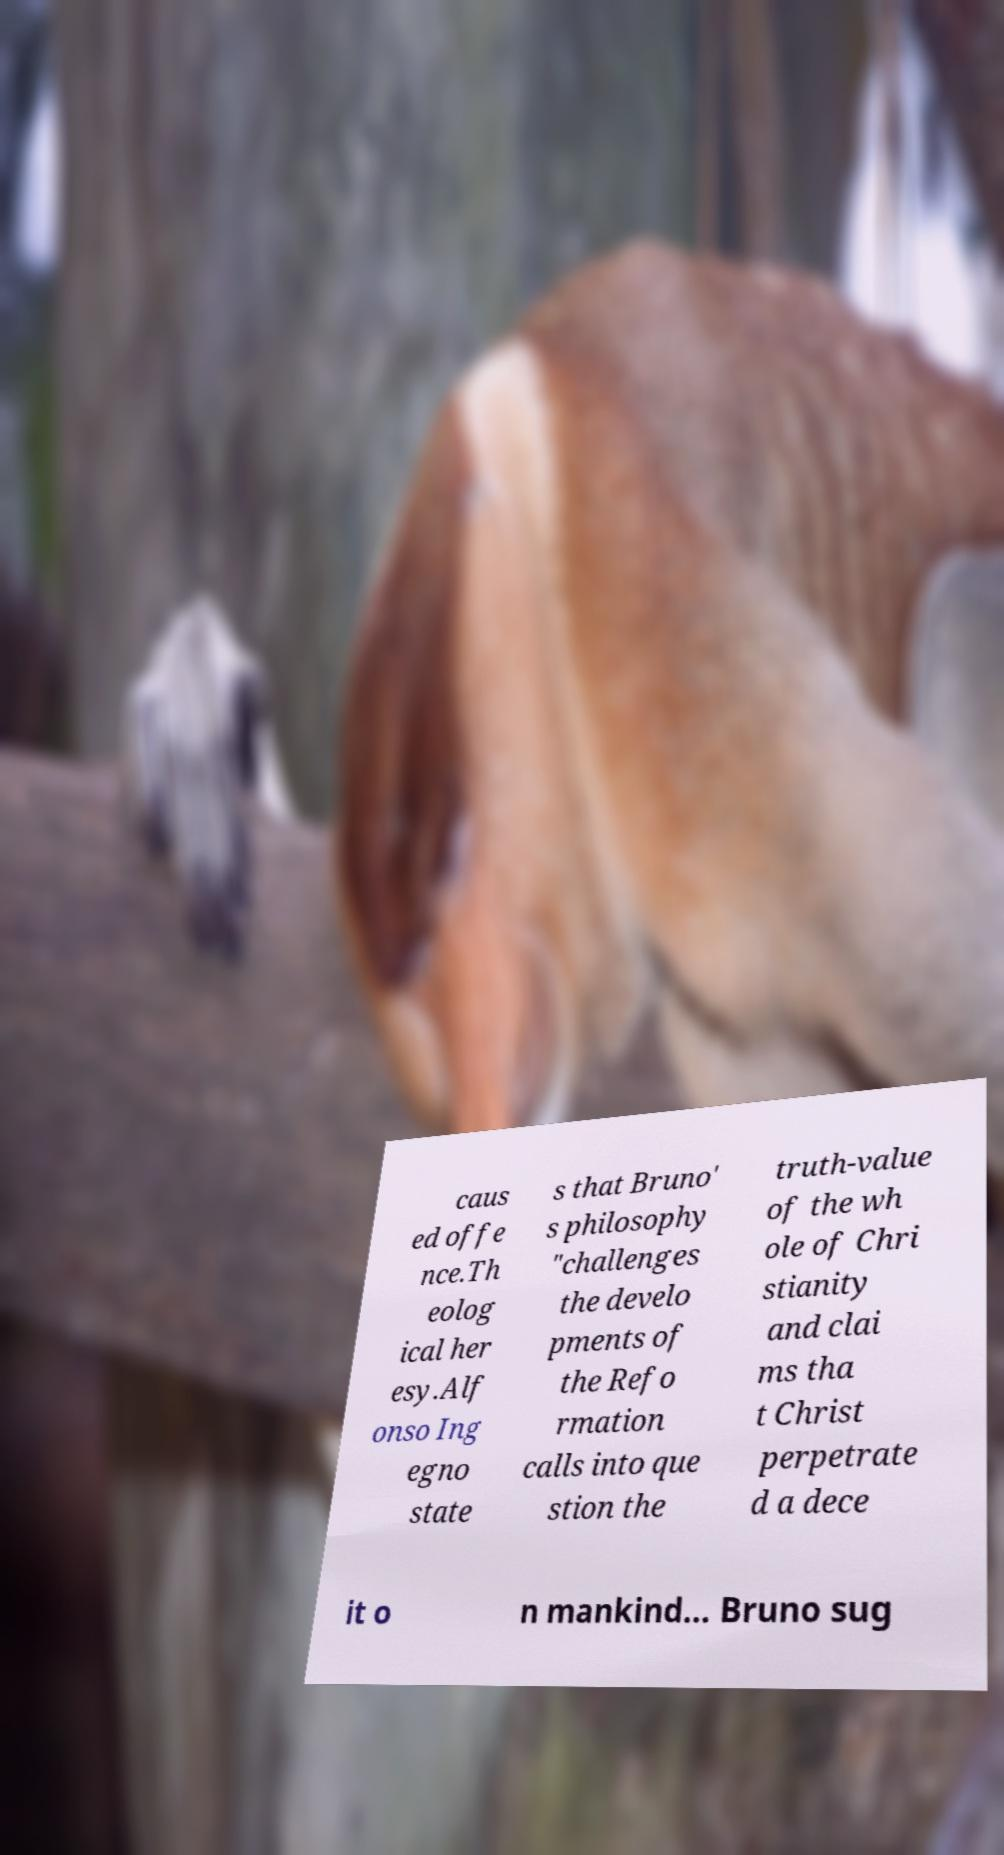Can you read and provide the text displayed in the image?This photo seems to have some interesting text. Can you extract and type it out for me? caus ed offe nce.Th eolog ical her esy.Alf onso Ing egno state s that Bruno' s philosophy "challenges the develo pments of the Refo rmation calls into que stion the truth-value of the wh ole of Chri stianity and clai ms tha t Christ perpetrate d a dece it o n mankind... Bruno sug 